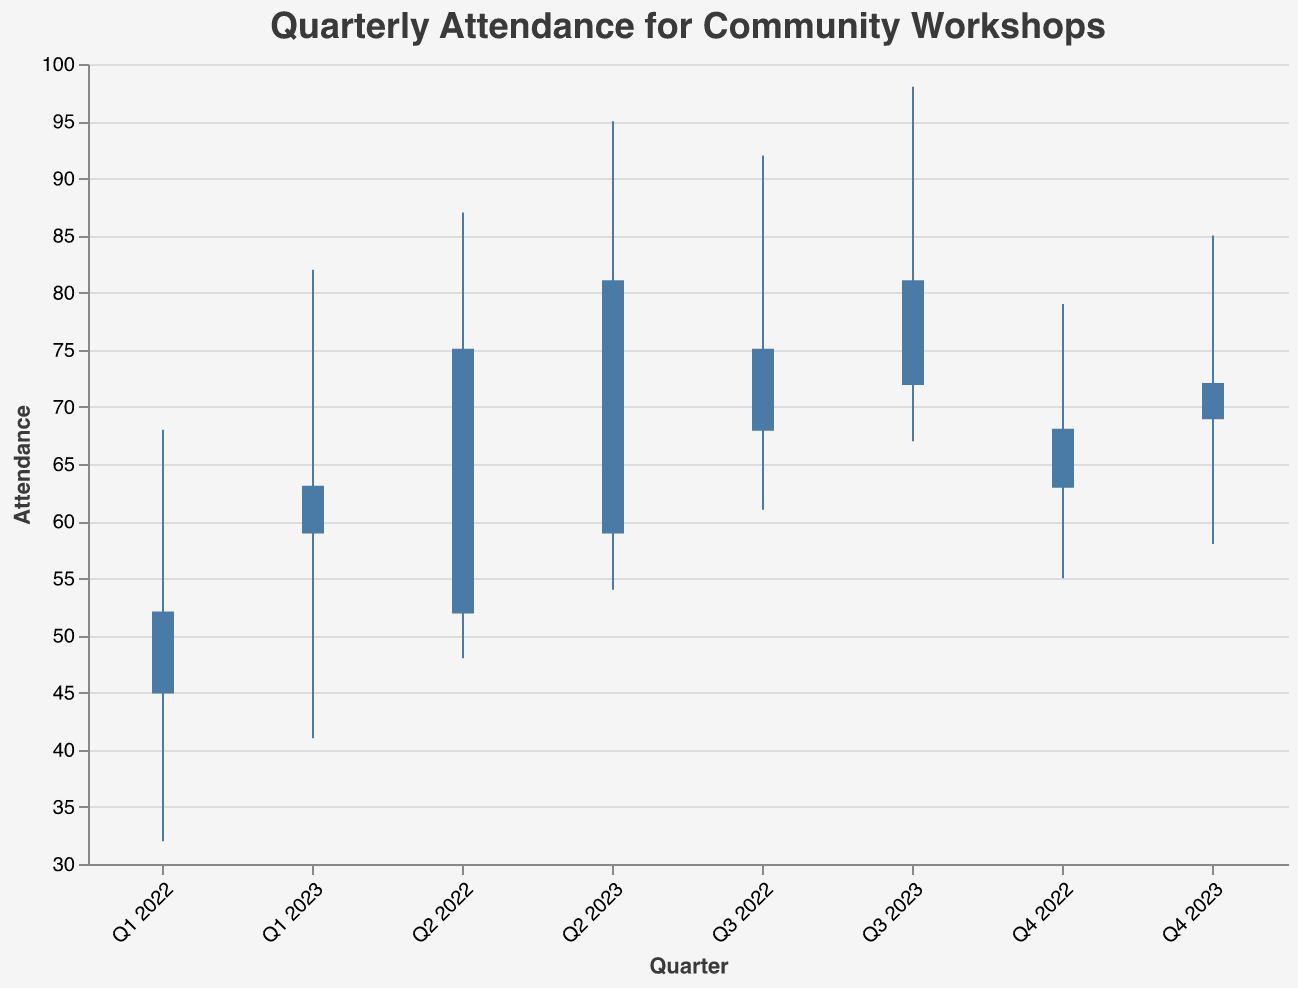What is the highest attendance in Q3 2023? The highest attendance value in Q3 2023 is represented by the "High" figure in the dataset, which is 98.
Answer: 98 What was the opening attendance figure for Q1 2022? The opening attendance for Q1 2022 is given in the dataset as 45.
Answer: 45 Between Q1 2022 and Q4 2022, which quarter had the highest closing attendance? Comparing the closing attendance figures for Q1 2022 (52), Q2 2022 (75), Q3 2022 (68), and Q4 2022 (63), the highest closing attendance was in Q2 2022 with 75.
Answer: Q2 2022 What is the difference between the highest and lowest attendance in Q2 2023? The highest attendance in Q2 2023 is 95, and the lowest is 54. The difference is 95 - 54 = 41.
Answer: 41 Which quarter had the lowest low attendance between Q1 2022 and Q4 2023? Comparing the low attendance figures for all quarters: Q1 2022 (32), Q2 2022 (48), Q3 2022 (61), Q4 2022 (55), Q1 2023 (41), Q2 2023 (54), Q3 2023 (67), Q4 2023 (58), the lowest is Q1 2022 with 32.
Answer: Q1 2022 Which quarter in 2023 had the highest closing attendance? Comparing the closing attendance figures for 2023 quarters: Q1 2023 (59), Q2 2023 (81), Q3 2023 (72), Q4 2023 (69), the highest closing attendance was in Q2 2023 with 81.
Answer: Q2 2023 What was the average closing attendance figure for 2022? The closing attendance figures for 2022 are: 52, 75, 68, 63. The average is calculated as (52 + 75 + 68 + 63) / 4 = 64.5.
Answer: 64.5 